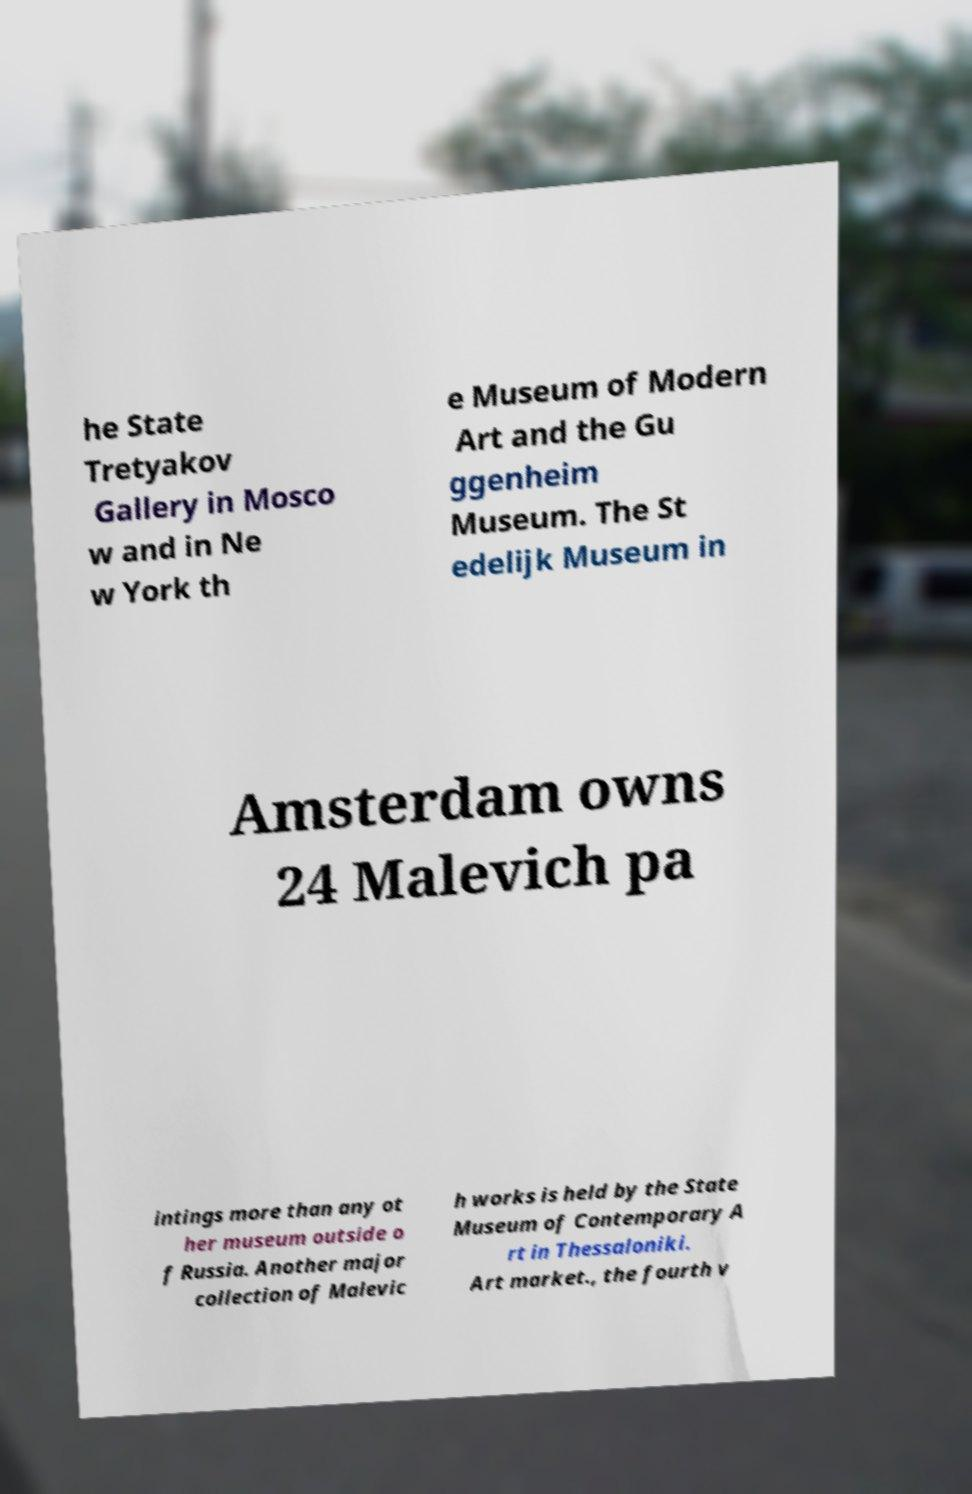Please identify and transcribe the text found in this image. he State Tretyakov Gallery in Mosco w and in Ne w York th e Museum of Modern Art and the Gu ggenheim Museum. The St edelijk Museum in Amsterdam owns 24 Malevich pa intings more than any ot her museum outside o f Russia. Another major collection of Malevic h works is held by the State Museum of Contemporary A rt in Thessaloniki. Art market., the fourth v 